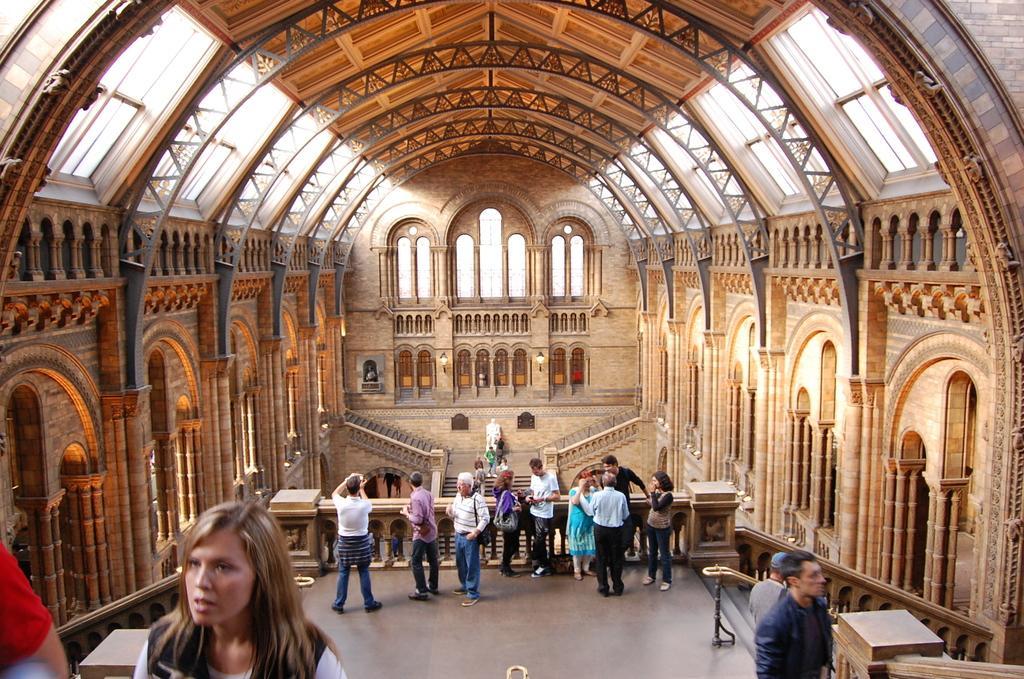Describe this image in one or two sentences. In the picture I can see these people are standing on the floor, here we can see ceiling, pillars, steps and stained glass in the background. Also, we can see a statue and lamps. 